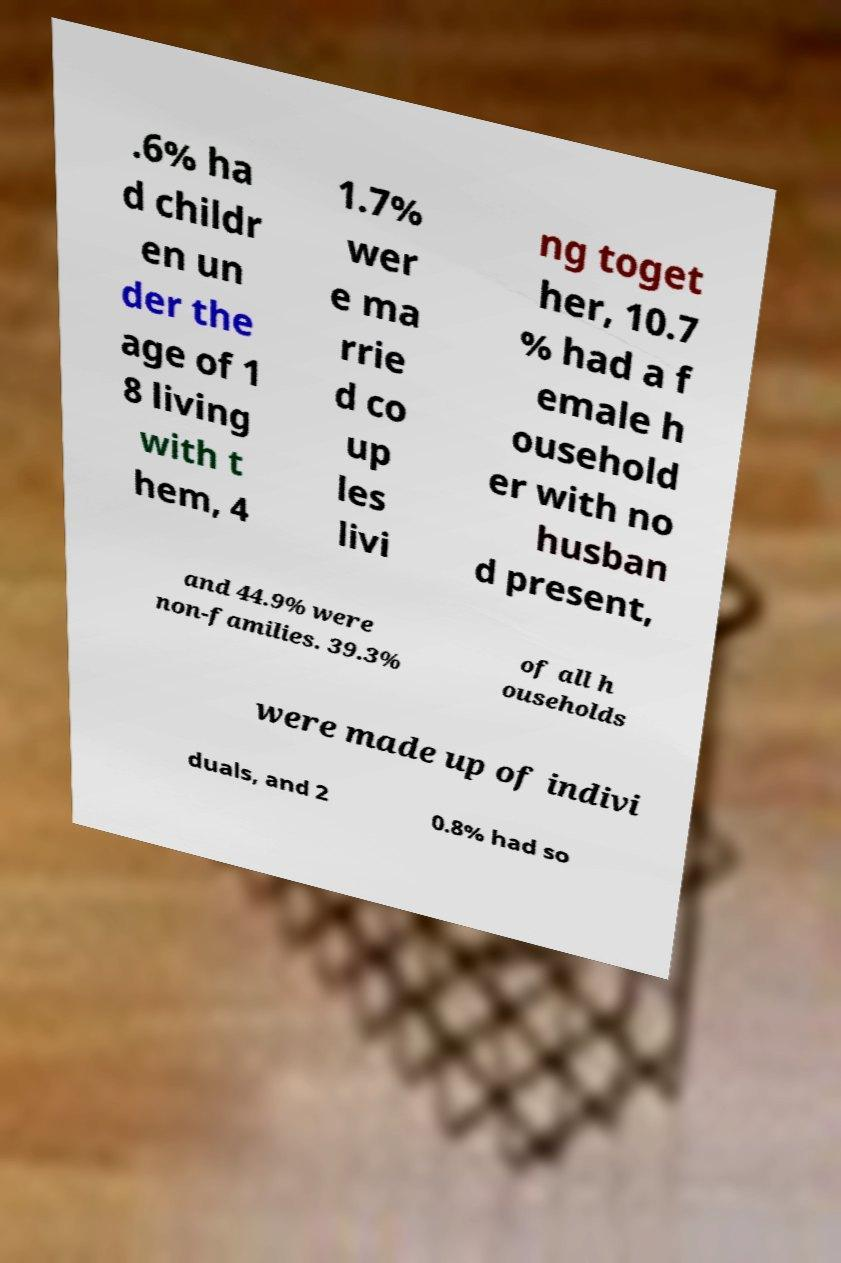Can you accurately transcribe the text from the provided image for me? .6% ha d childr en un der the age of 1 8 living with t hem, 4 1.7% wer e ma rrie d co up les livi ng toget her, 10.7 % had a f emale h ousehold er with no husban d present, and 44.9% were non-families. 39.3% of all h ouseholds were made up of indivi duals, and 2 0.8% had so 